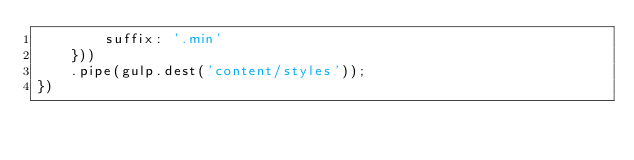Convert code to text. <code><loc_0><loc_0><loc_500><loc_500><_JavaScript_>        suffix: '.min'
    }))
    .pipe(gulp.dest('content/styles'));
})</code> 